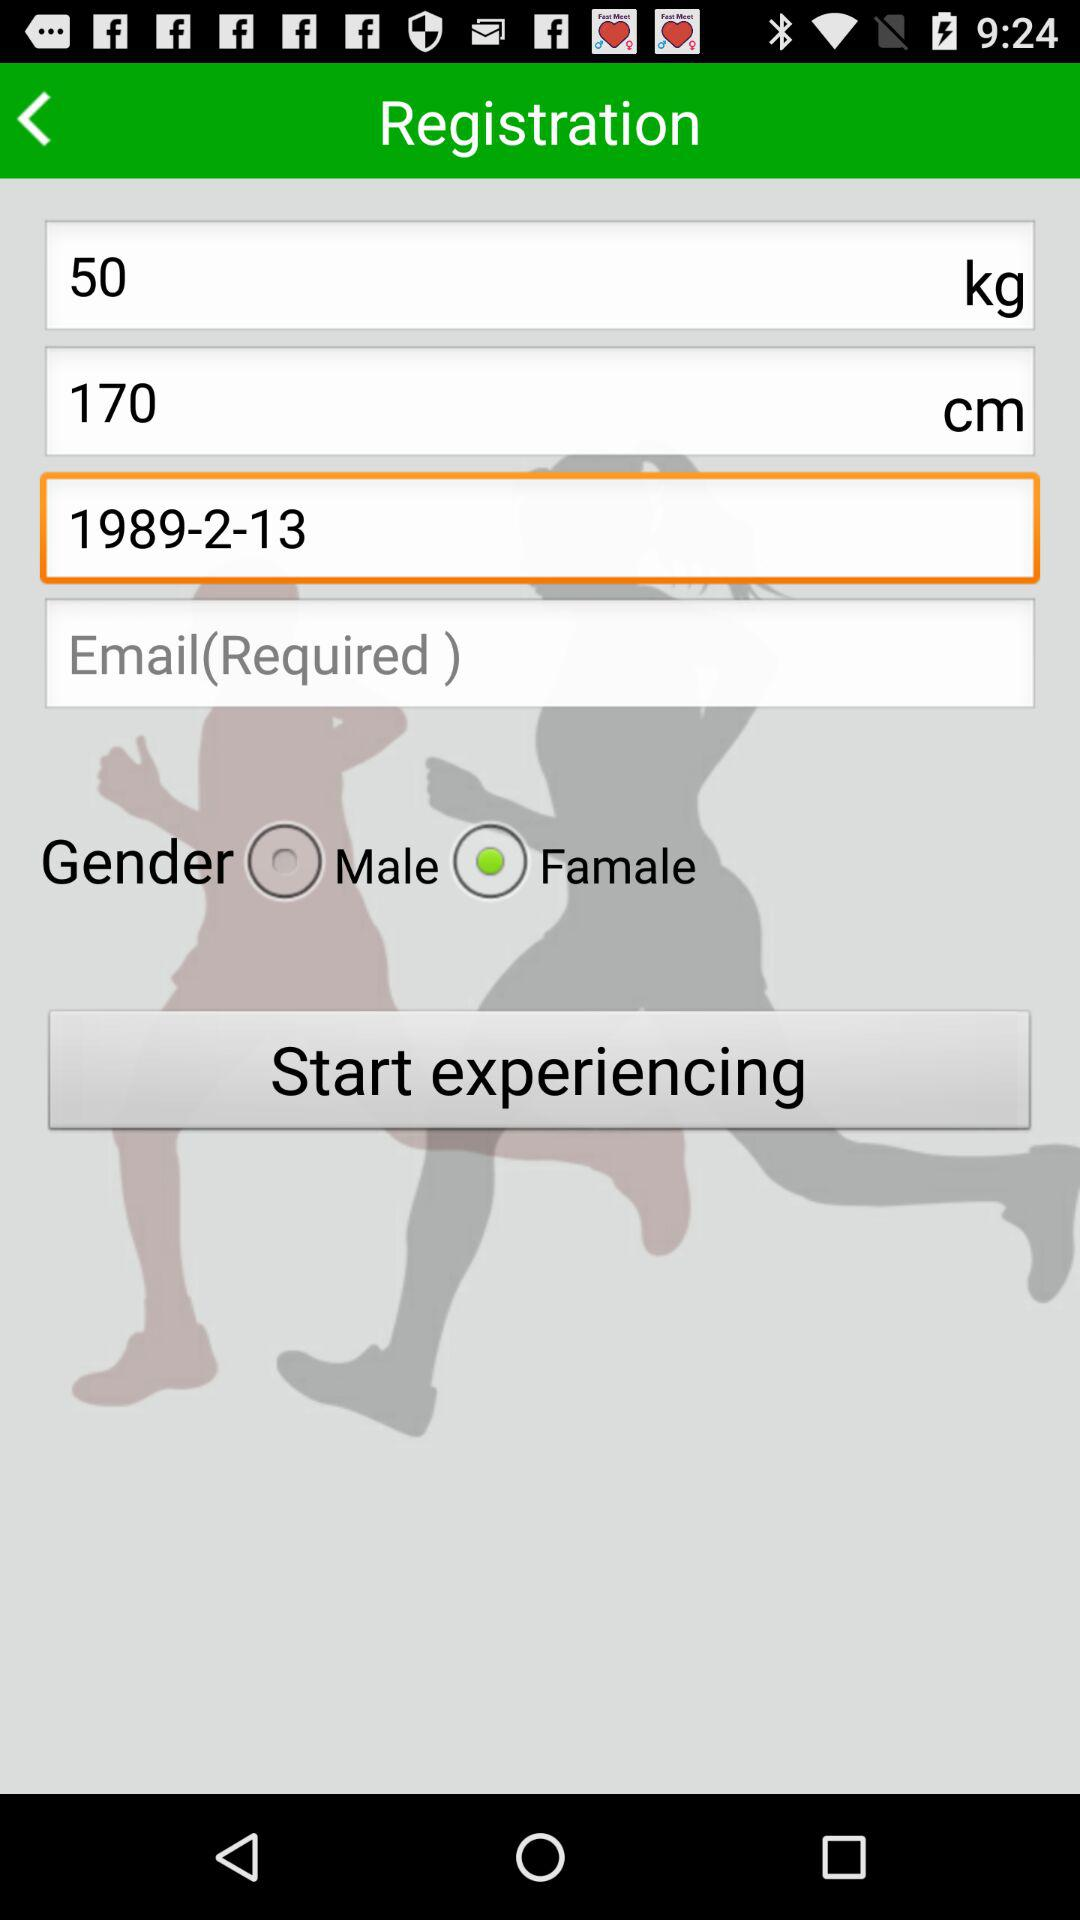How many text inputs are there for gender?
Answer the question using a single word or phrase. 2 